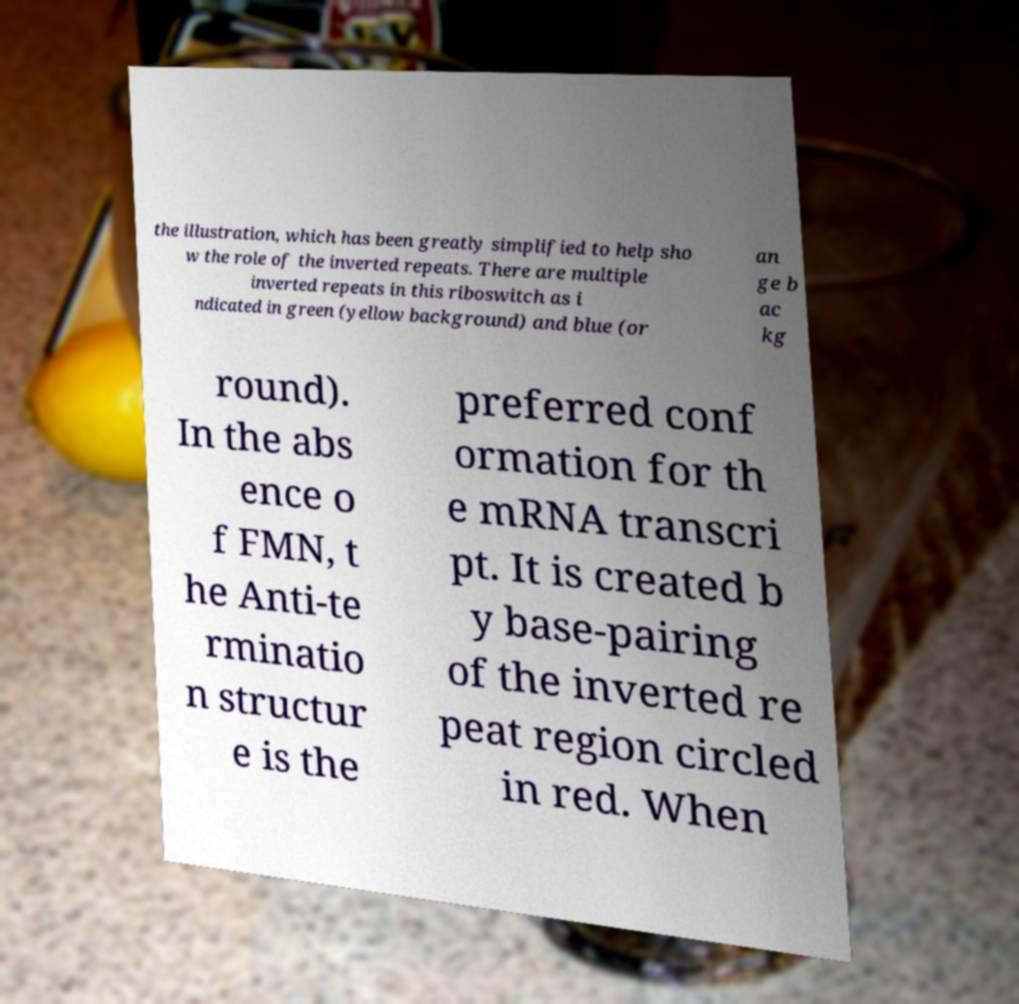Could you assist in decoding the text presented in this image and type it out clearly? the illustration, which has been greatly simplified to help sho w the role of the inverted repeats. There are multiple inverted repeats in this riboswitch as i ndicated in green (yellow background) and blue (or an ge b ac kg round). In the abs ence o f FMN, t he Anti-te rminatio n structur e is the preferred conf ormation for th e mRNA transcri pt. It is created b y base-pairing of the inverted re peat region circled in red. When 